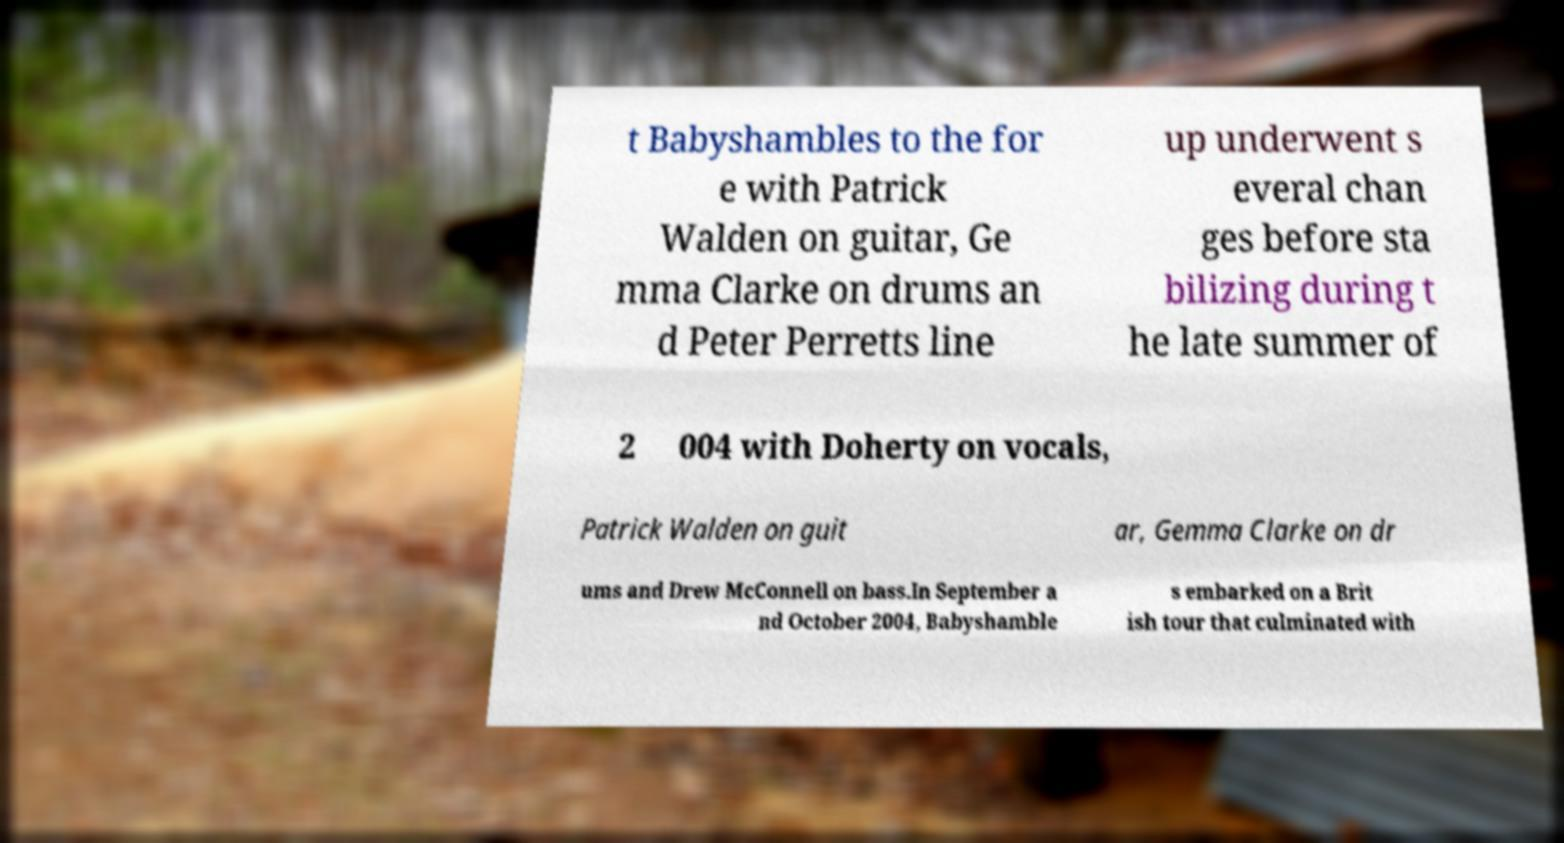Can you accurately transcribe the text from the provided image for me? t Babyshambles to the for e with Patrick Walden on guitar, Ge mma Clarke on drums an d Peter Perretts line up underwent s everal chan ges before sta bilizing during t he late summer of 2 004 with Doherty on vocals, Patrick Walden on guit ar, Gemma Clarke on dr ums and Drew McConnell on bass.In September a nd October 2004, Babyshamble s embarked on a Brit ish tour that culminated with 